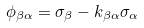Convert formula to latex. <formula><loc_0><loc_0><loc_500><loc_500>\phi _ { \beta \alpha } = \sigma _ { \beta } - k _ { \beta \alpha } \sigma _ { \alpha }</formula> 